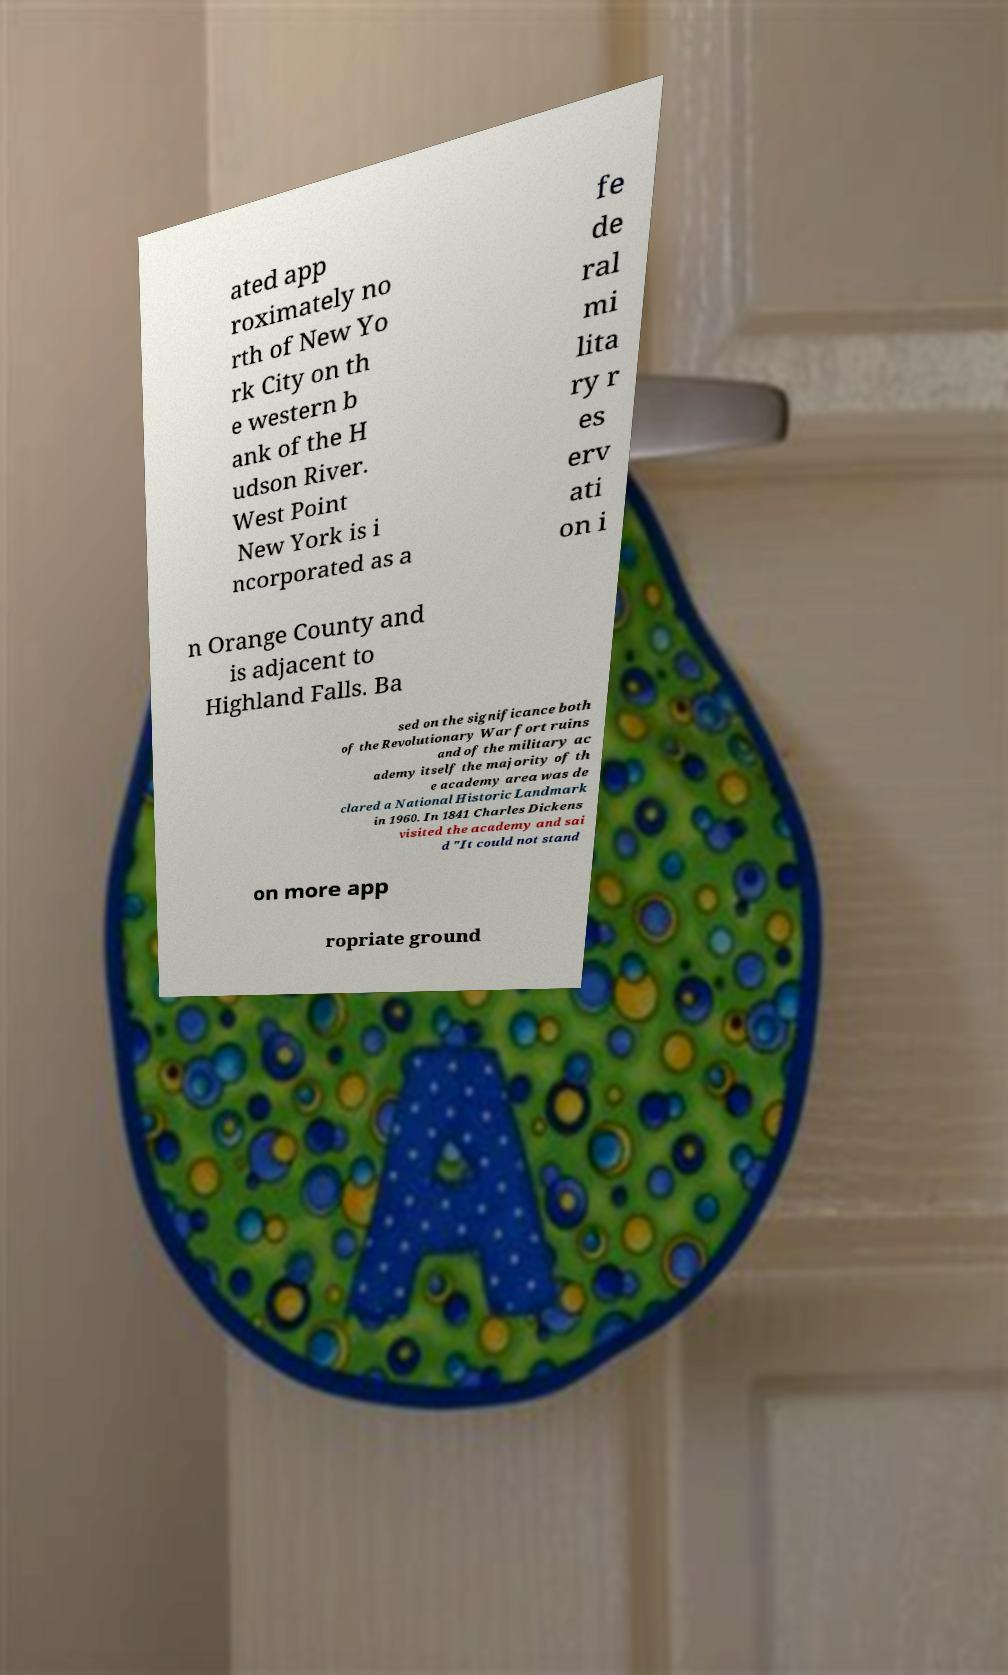Can you accurately transcribe the text from the provided image for me? ated app roximately no rth of New Yo rk City on th e western b ank of the H udson River. West Point New York is i ncorporated as a fe de ral mi lita ry r es erv ati on i n Orange County and is adjacent to Highland Falls. Ba sed on the significance both of the Revolutionary War fort ruins and of the military ac ademy itself the majority of th e academy area was de clared a National Historic Landmark in 1960. In 1841 Charles Dickens visited the academy and sai d "It could not stand on more app ropriate ground 